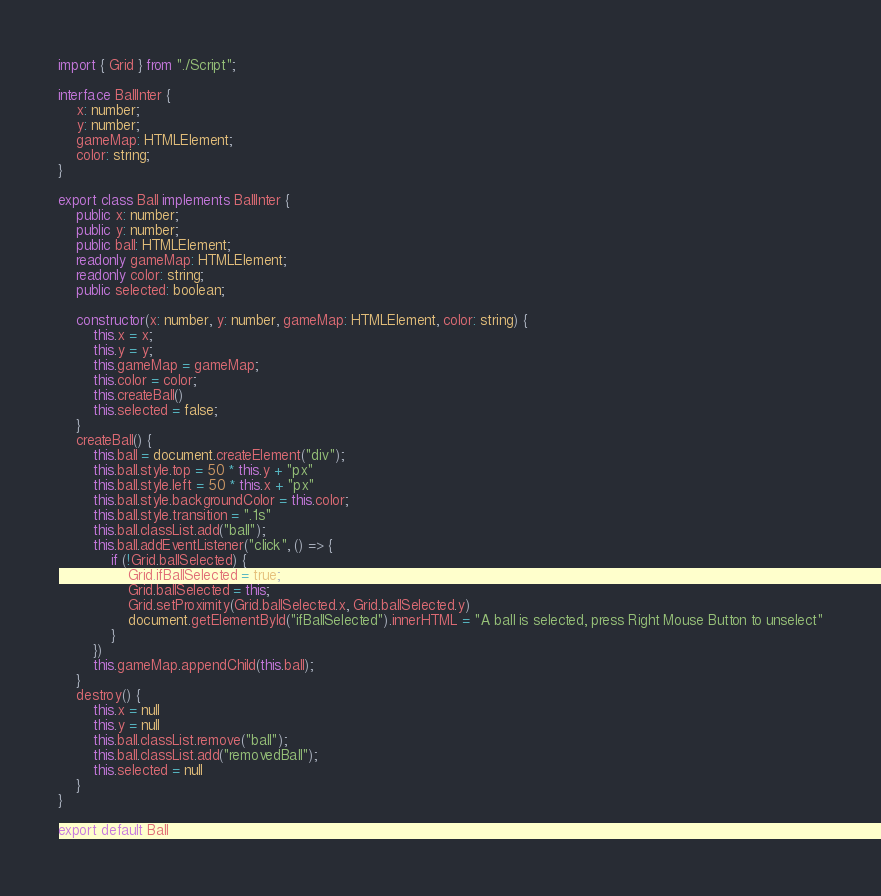Convert code to text. <code><loc_0><loc_0><loc_500><loc_500><_TypeScript_>import { Grid } from "./Script";

interface BallInter {
    x: number;
    y: number;
    gameMap: HTMLElement;
    color: string;
}

export class Ball implements BallInter {
    public x: number;
    public y: number;
    public ball: HTMLElement;
    readonly gameMap: HTMLElement;
    readonly color: string;
    public selected: boolean;

    constructor(x: number, y: number, gameMap: HTMLElement, color: string) {
        this.x = x;
        this.y = y;
        this.gameMap = gameMap;
        this.color = color;
        this.createBall()
        this.selected = false;
    }
    createBall() {
        this.ball = document.createElement("div");
        this.ball.style.top = 50 * this.y + "px"
        this.ball.style.left = 50 * this.x + "px"
        this.ball.style.backgroundColor = this.color;
        this.ball.style.transition = ".1s"
        this.ball.classList.add("ball");
        this.ball.addEventListener("click", () => {
            if (!Grid.ballSelected) {
                Grid.ifBallSelected = true;
                Grid.ballSelected = this;
                Grid.setProximity(Grid.ballSelected.x, Grid.ballSelected.y)
                document.getElementById("ifBallSelected").innerHTML = "A ball is selected, press Right Mouse Button to unselect"
            }
        })
        this.gameMap.appendChild(this.ball);
    }
    destroy() {
        this.x = null
        this.y = null
        this.ball.classList.remove("ball");
        this.ball.classList.add("removedBall");
        this.selected = null
    }
}

export default Ball</code> 